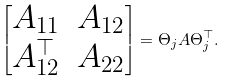Convert formula to latex. <formula><loc_0><loc_0><loc_500><loc_500>\begin{bmatrix} A _ { 1 1 } & A _ { 1 2 } \\ A _ { 1 2 } ^ { \top } & A _ { 2 2 } \end{bmatrix} = \Theta _ { j } A \Theta _ { j } ^ { \top } .</formula> 